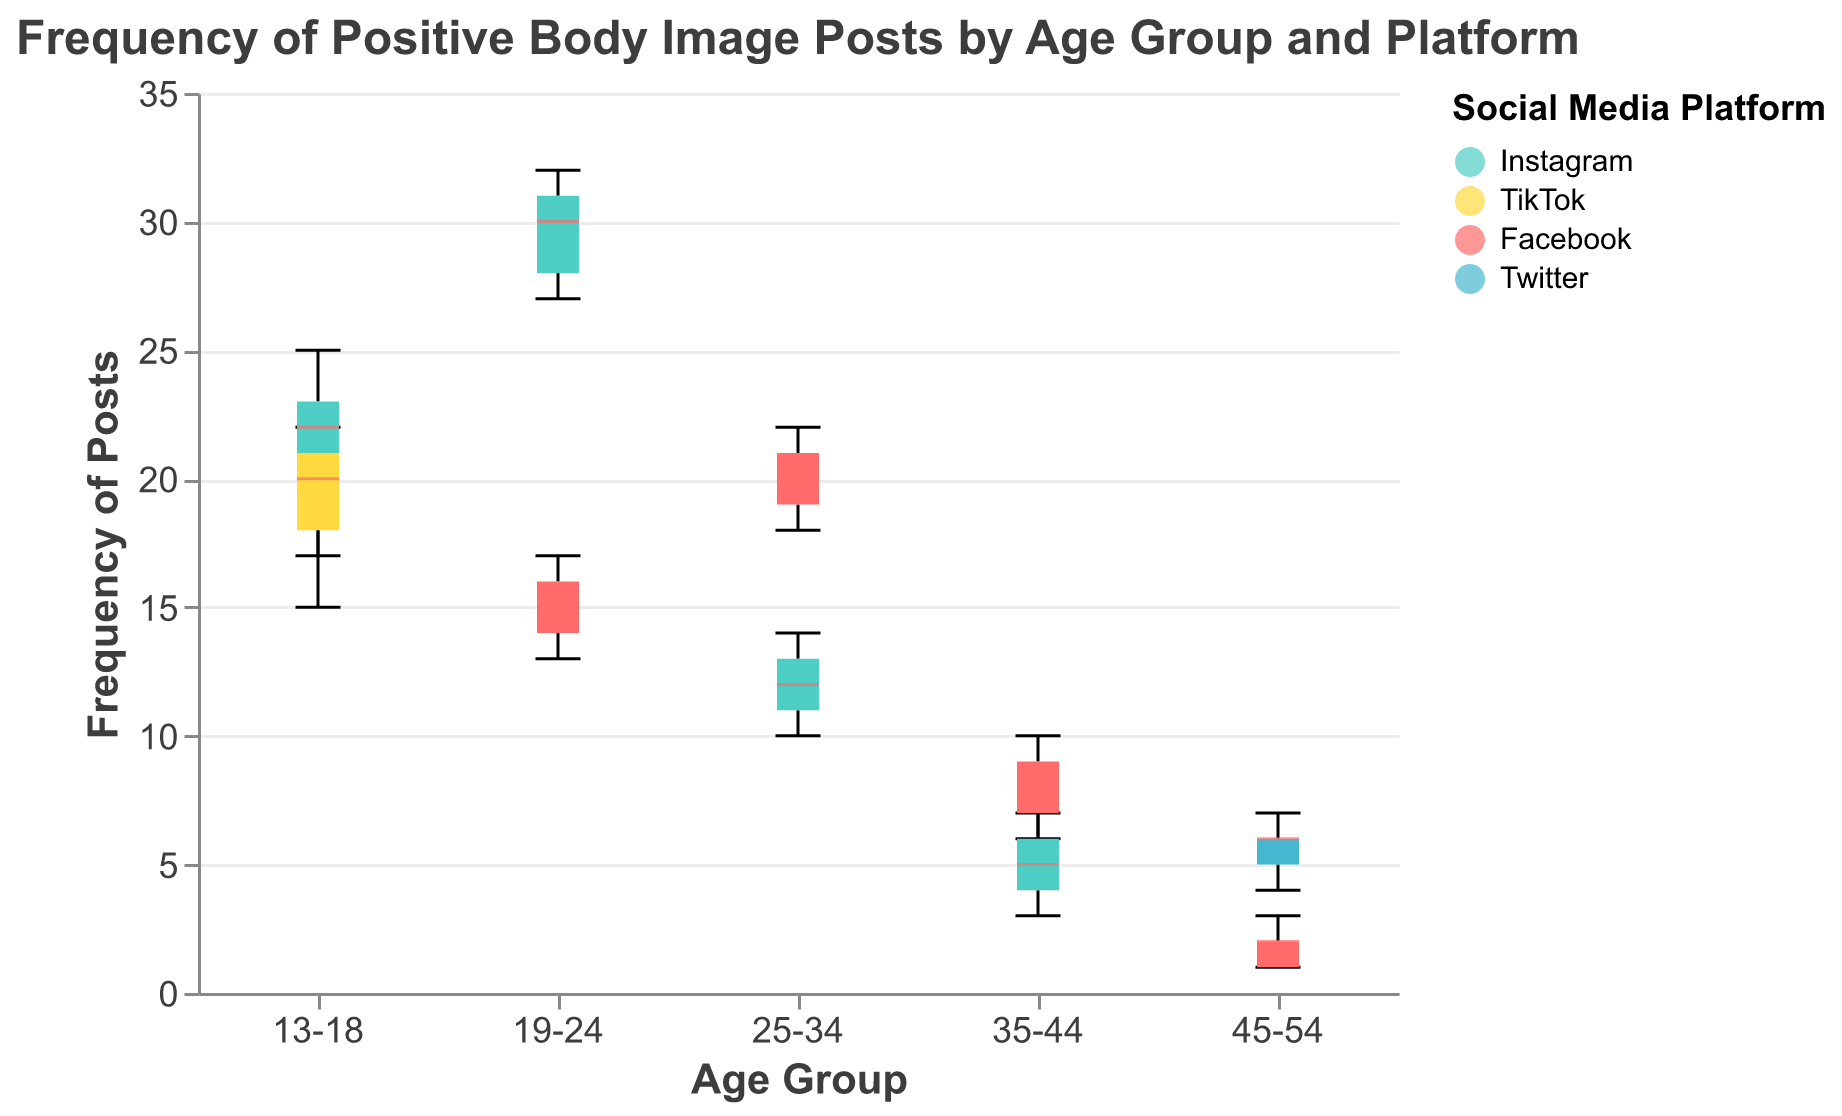What is the title of the figure? The title of the figure is typically displayed at the top and provides a summary of what the chart represents. Here, it is clearly stated.
Answer: Frequency of Positive Body Image Posts by Age Group and Platform What platforms are included in the box plot? The legend shows the different social media platforms represented in the data. Each platform is denoted by a different color.
Answer: Instagram, TikTok, Facebook, Twitter Which age group has the highest median frequency of positive body image posts on Instagram? By examining the boxes for Instagram across different age groups, the one with the highest median (line inside the box) is identified.
Answer: 19-24 In which age group does TikTok show a higher median frequency of positive body image posts compared to Instagram? Compare the median lines of Instagram and TikTok boxes for each age group to find the one where TikTok's median is higher.
Answer: 13-18 How does the frequency range of positive body image posts on Facebook for the 35-44 age group compare to that of Instagram in the same group? The frequency range is determined by the whiskers (min and max values) of the box plots. Compare these ranges for Facebook and Instagram in the 35-44 age group.
Answer: Facebook has a wider range (6-10) compared to Instagram (3-7) Which age group and platform combination has the lowest minimum frequency of posts? Look for the lowest whisker among all box plots which indicates the minimum. Compare across age groups and platforms to identify the lowest.
Answer: Facebook, 45-54 Determine the IQR (Interquartile Range) for Instagram in the 25-34 age group. The IQR is calculated as the difference between the first quartile (Q1) and the third quartile (Q3) in the box plot for Instagram in the 25-34 age group.
Answer: Q3:14, Q1:11, IQR = 14 - 11 = 3 What can be inferred about the consistency of positive body image posts for the 45-54 age group across platforms? Consistency can be deduced from the spread and whiskers of the box plots for different platforms in the 45-54 age group. Smaller boxes and shorter whiskers indicate more consistency.
Answer: Highly consistent on Facebook, more varied on Twitter Compare the frequency of positive body image posts between TikTok and Facebook for the 13-18 age group. Compare the box plots for TikTok and Facebook in terms of median, IQR, and the overall range of frequencies for the 13-18 age group.
Answer: TikTok median is higher; Facebook has a wider range What color represents Twitter in the plot, and which age group shows data for it? Find Twitter in the legend to determine the associated color. Then identify which age group's box plot is in that color.
Answer: Light blue; 45-54 